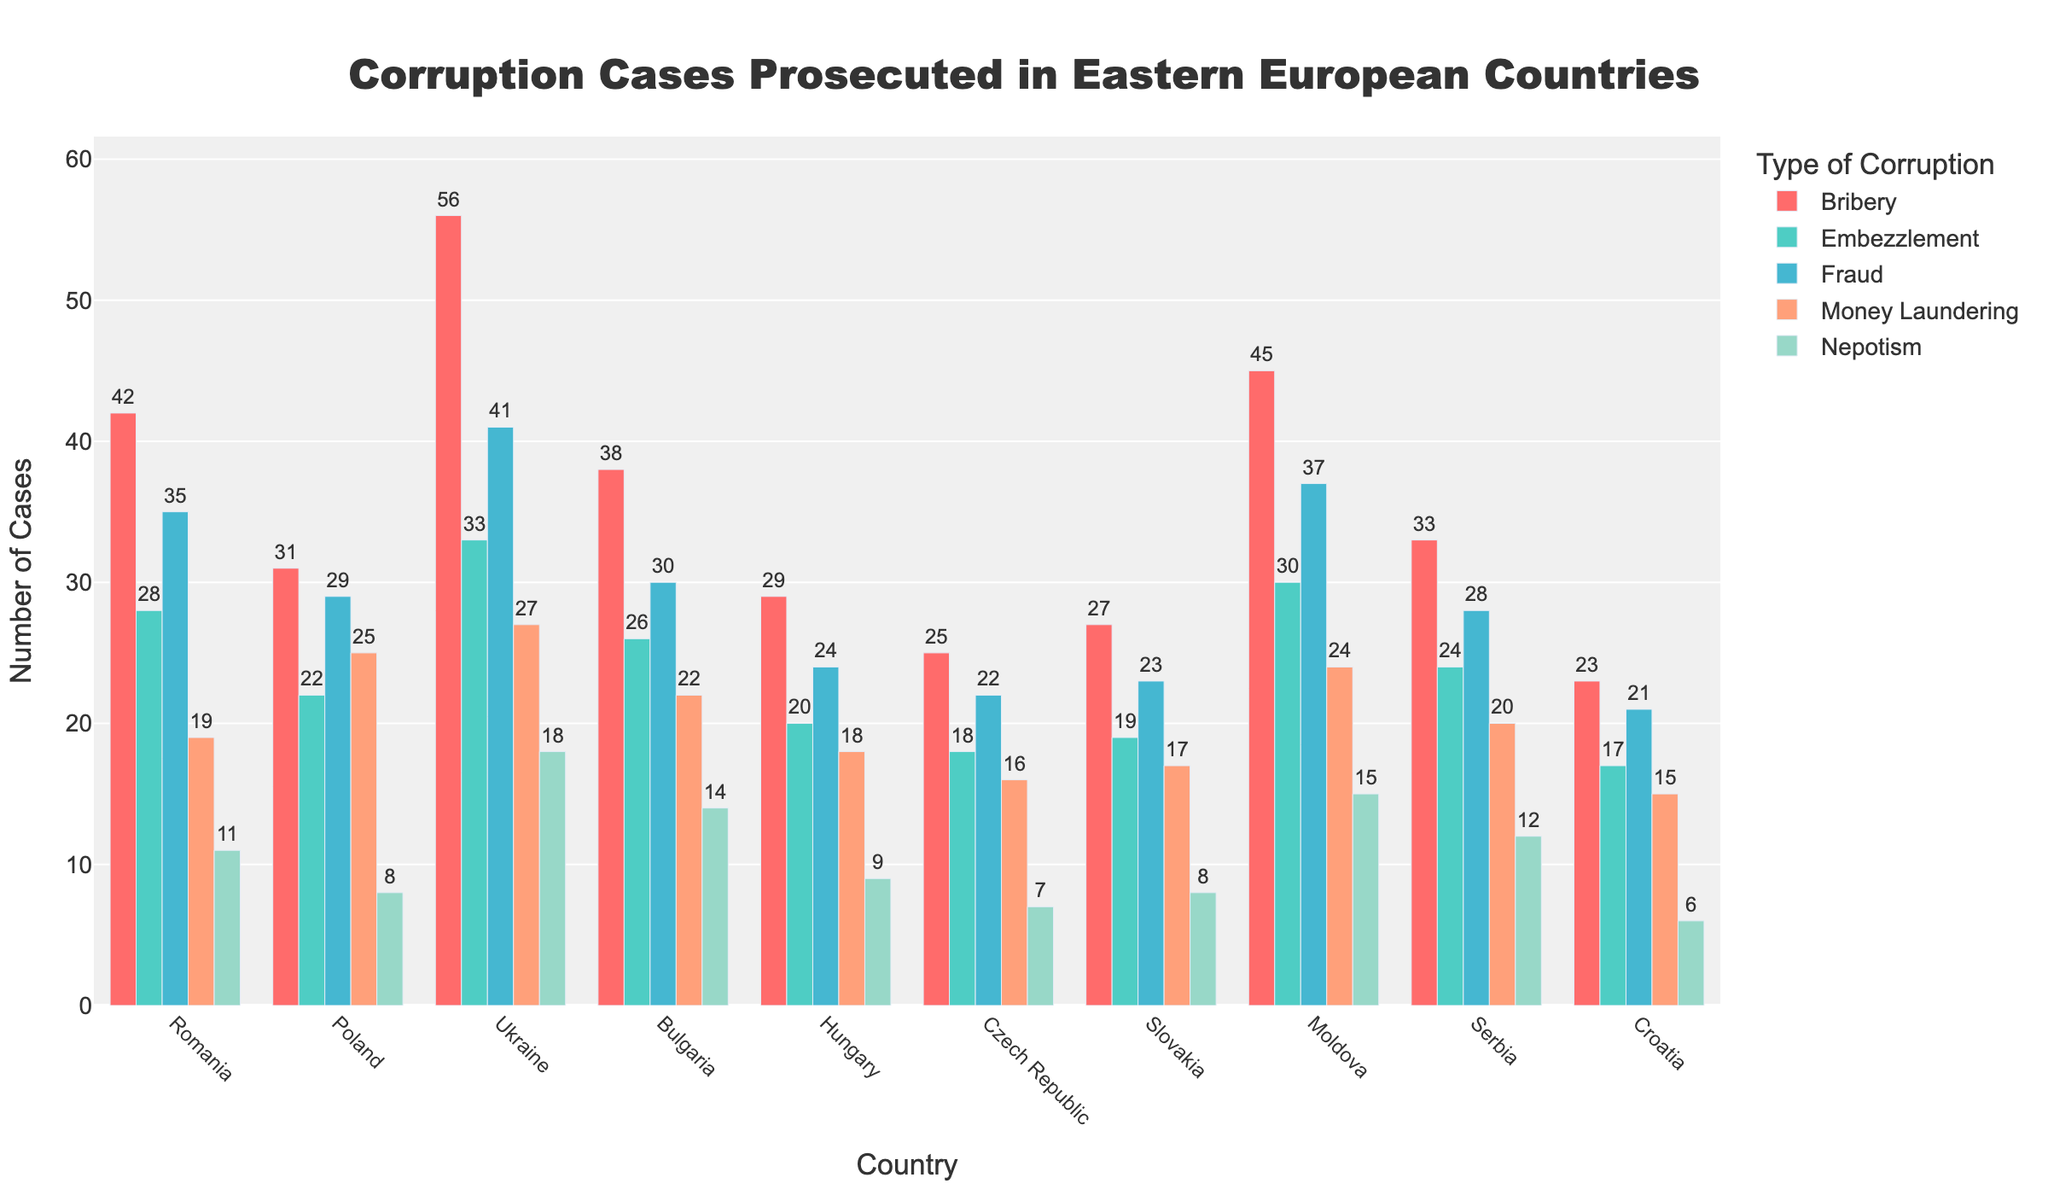Which country has the highest number of money laundering cases? Looking at the bars for Money Laundering, the bar corresponding to Ukraine is the tallest, indicating it has the highest number of cases.
Answer: Ukraine Which type of corruption is most frequently prosecuted in Romania? For Romania, the tallest bar is for Bribery.
Answer: Bribery How many more fraud cases than bribery cases were prosecuted in Croatia? In Croatia, there are 23 bribery cases and 21 fraud cases. Using subtraction, 23 (bribery) - 21 (fraud) = 2.
Answer: 2 Which country has the least number of nepotism cases, and how many are there? The shortest bar for Nepotism is in Croatia with 6 cases.
Answer: Croatia, 6 Compare the number of embezzlement cases in Poland and Hungary. Which country has more, and by how much? Poland has 22 embezzlement cases, and Hungary has 20. Subtract to find the difference: 22 - 20 = 2. Therefore, Poland has 2 more cases than Hungary.
Answer: Poland, 2 What is the sum of all corruption cases in Moldova? Adding all types for Moldova: 45 (Bribery) + 30 (Embezzlement) + 37 (Fraud) + 24 (Money Laundering) + 15 (Nepotism) = 151.
Answer: 151 Which type of corruption is least prosecuted in Slovakia? The shortest bar for Slovakia corresponds to Nepotism with 8 cases.
Answer: Nepotism How do the numbers of bribery and fraud cases in Bulgaria compare? Bulgaria has 38 bribery cases and 30 fraud cases.
Answer: Bribery cases are more by 8 What is the difference in the number of money laundering cases between the country with the highest and the country with the lowest? Ukraine has the highest with 27, and Croatia the lowest with 15. Difference: 27 - 15 = 12.
Answer: 12 Find the average number of fraud cases across all countries. Sum of fraud cases: 35 + 29 + 41 + 30 + 24 + 22 + 23 + 37 + 28 + 21 = 290. There are 10 countries, so average = 290 / 10 = 29.
Answer: 29 